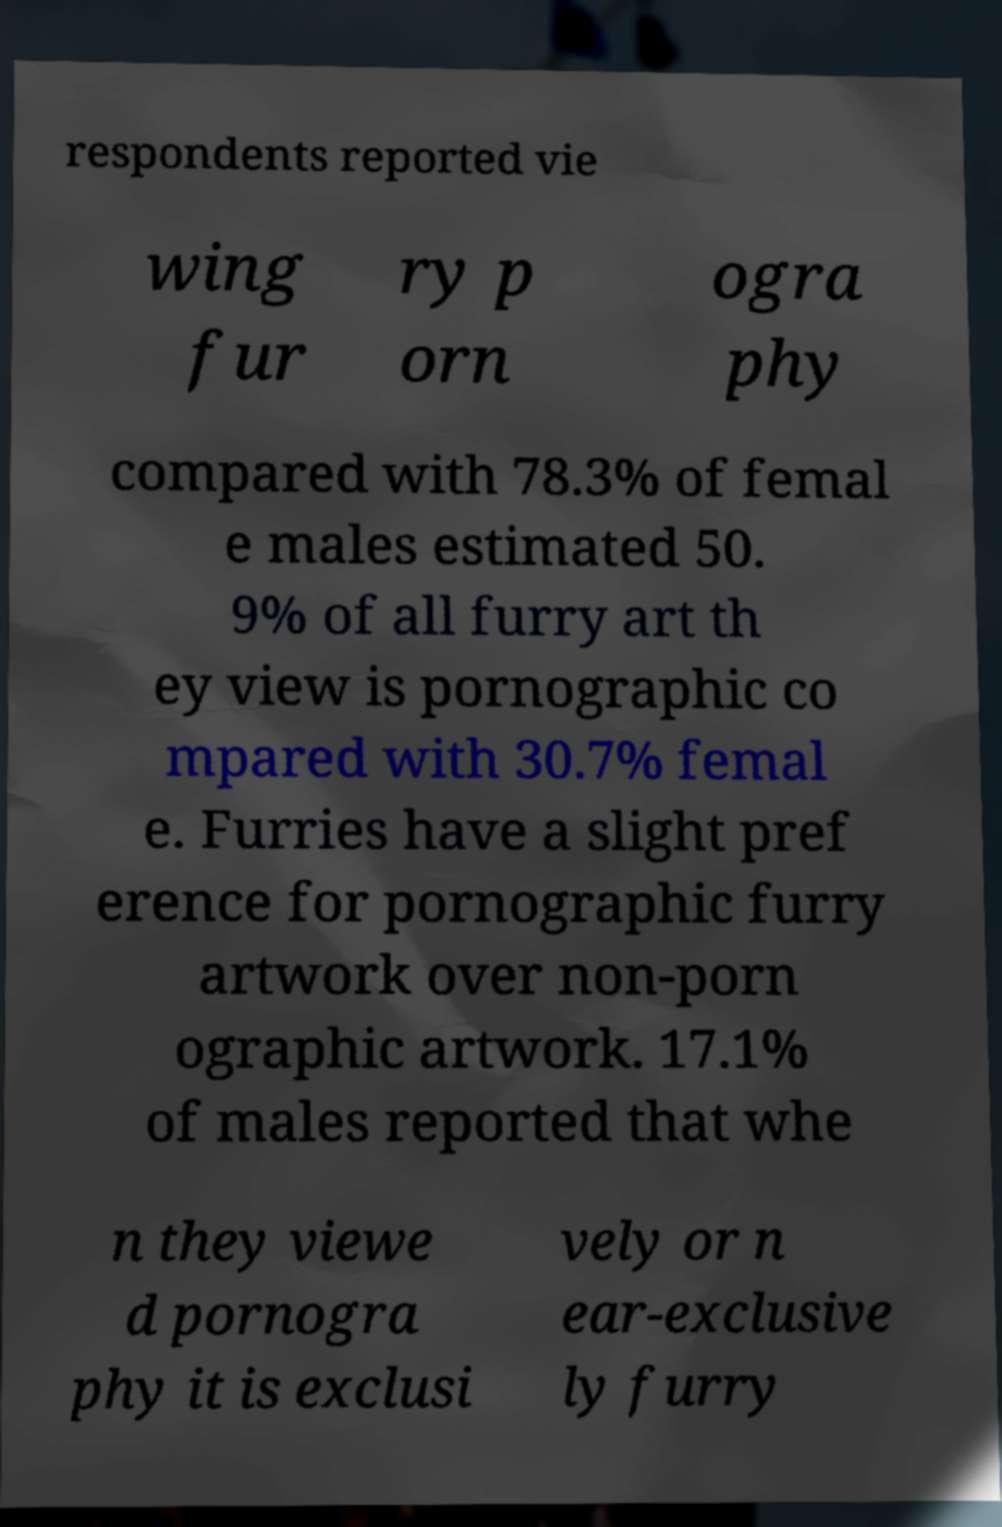What messages or text are displayed in this image? I need them in a readable, typed format. respondents reported vie wing fur ry p orn ogra phy compared with 78.3% of femal e males estimated 50. 9% of all furry art th ey view is pornographic co mpared with 30.7% femal e. Furries have a slight pref erence for pornographic furry artwork over non-porn ographic artwork. 17.1% of males reported that whe n they viewe d pornogra phy it is exclusi vely or n ear-exclusive ly furry 